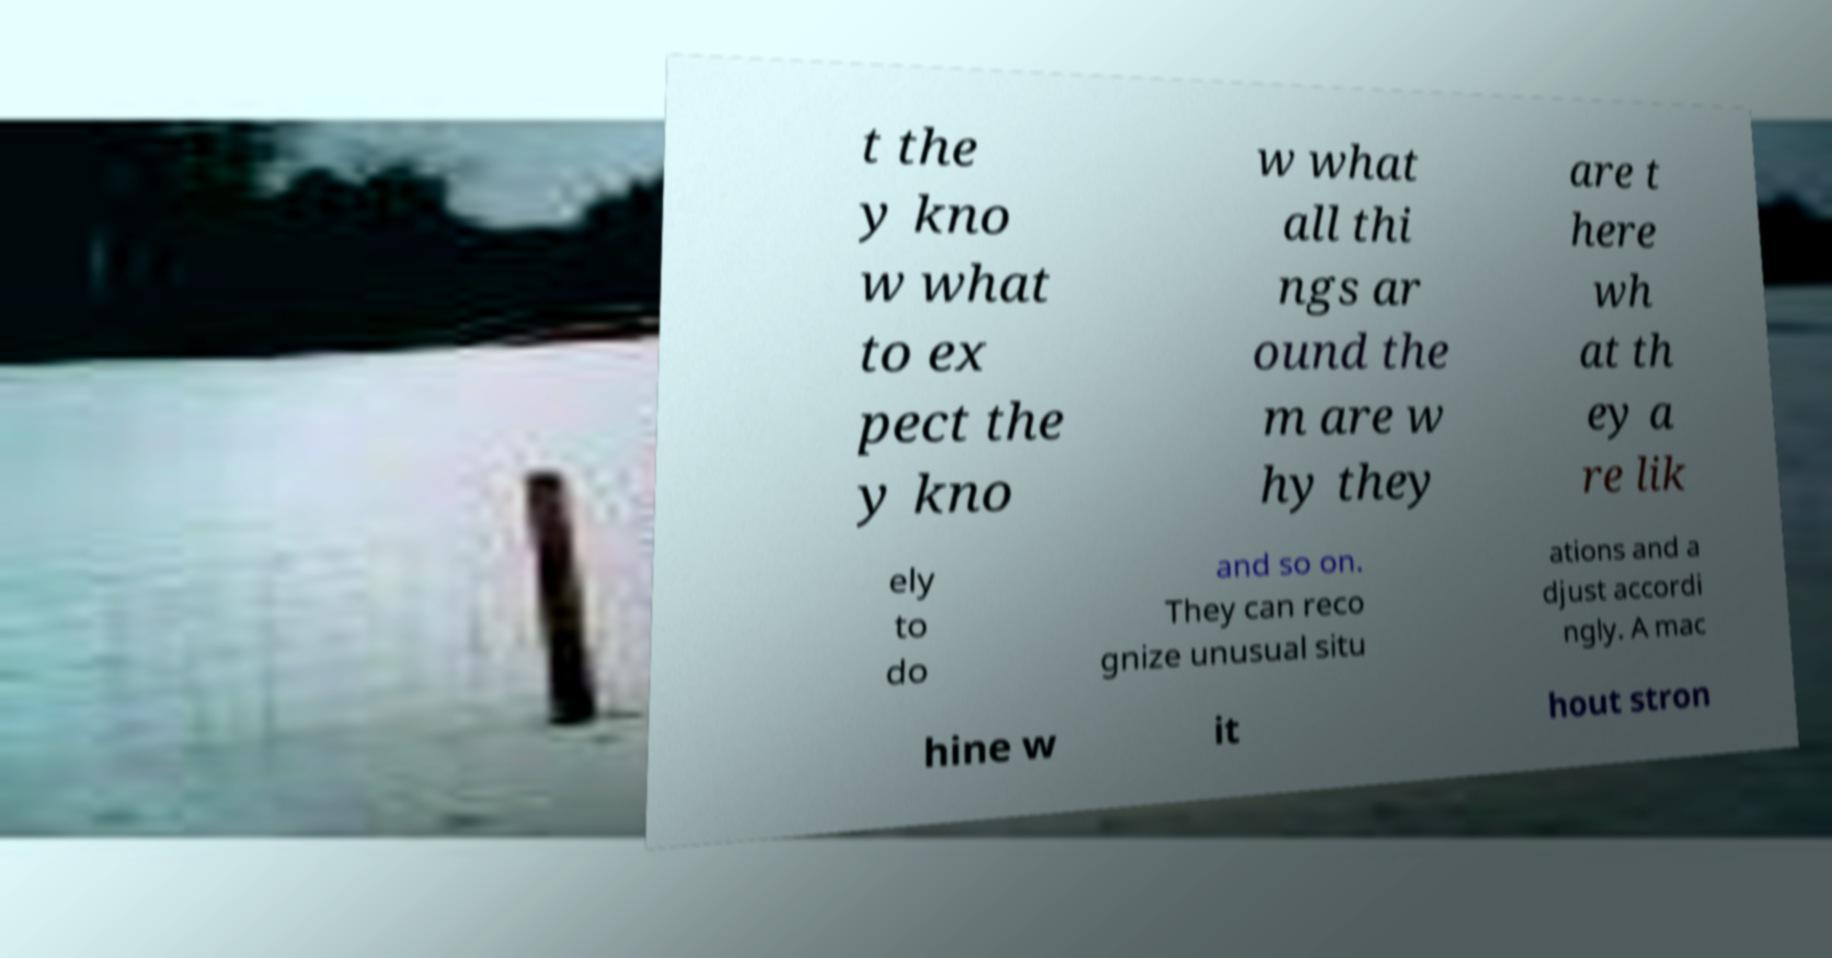What messages or text are displayed in this image? I need them in a readable, typed format. t the y kno w what to ex pect the y kno w what all thi ngs ar ound the m are w hy they are t here wh at th ey a re lik ely to do and so on. They can reco gnize unusual situ ations and a djust accordi ngly. A mac hine w it hout stron 